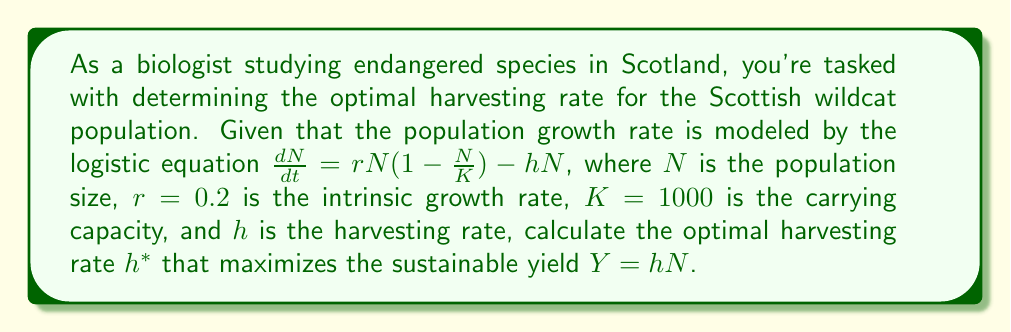Help me with this question. To find the optimal harvesting rate, we'll follow these steps:

1) The sustainable yield occurs when the population is at equilibrium, i.e., $\frac{dN}{dt} = 0$. Set the equation equal to zero:

   $$rN(1-\frac{N}{K}) - hN = 0$$

2) Solve for $N$ in terms of $h$:

   $$rN - \frac{rN^2}{K} - hN = 0$$
   $$N(r - \frac{rN}{K} - h) = 0$$

   This equation is satisfied when $N = 0$ or when $r - \frac{rN}{K} - h = 0$

3) We're interested in the non-zero solution. Solve for $N$:

   $$r - \frac{rN}{K} - h = 0$$
   $$\frac{rN}{K} = r - h$$
   $$N = K(1 - \frac{h}{r})$$

4) The sustainable yield $Y$ is given by $hN$. Substitute our expression for $N$:

   $$Y = hK(1 - \frac{h}{r})$$

5) To find the maximum yield, differentiate $Y$ with respect to $h$ and set it to zero:

   $$\frac{dY}{dh} = K(1 - \frac{h}{r}) - K\frac{h}{r} = 0$$
   $$1 - \frac{h}{r} - \frac{h}{r} = 0$$
   $$1 - \frac{2h}{r} = 0$$

6) Solve for $h$:

   $$\frac{2h}{r} = 1$$
   $$h = \frac{r}{2}$$

7) Therefore, the optimal harvesting rate $h^*$ is $\frac{r}{2} = \frac{0.2}{2} = 0.1$
Answer: $h^* = 0.1$ 